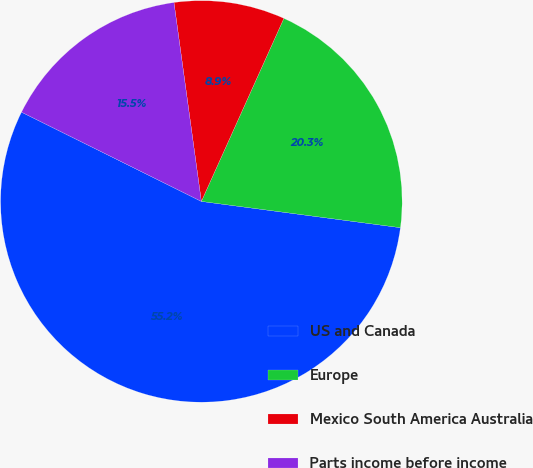Convert chart. <chart><loc_0><loc_0><loc_500><loc_500><pie_chart><fcel>US and Canada<fcel>Europe<fcel>Mexico South America Australia<fcel>Parts income before income<nl><fcel>55.25%<fcel>20.35%<fcel>8.92%<fcel>15.49%<nl></chart> 